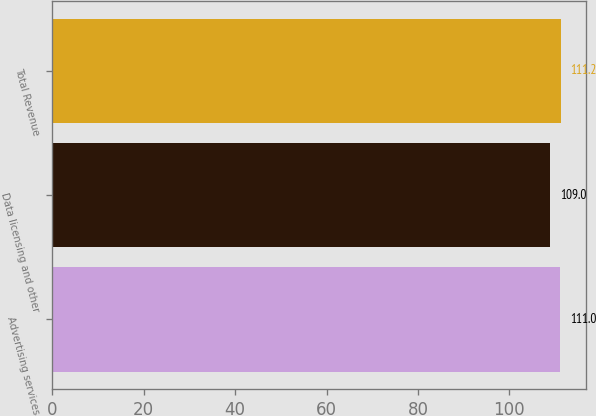<chart> <loc_0><loc_0><loc_500><loc_500><bar_chart><fcel>Advertising services<fcel>Data licensing and other<fcel>Total Revenue<nl><fcel>111<fcel>109<fcel>111.2<nl></chart> 